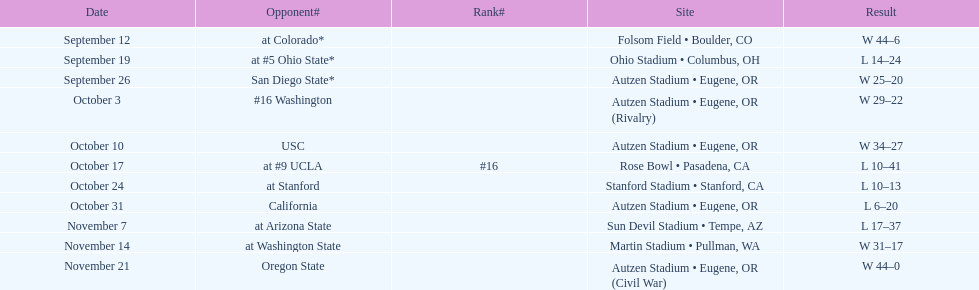Between september 26 and october 24, how many games were played in eugene, or? 3. 